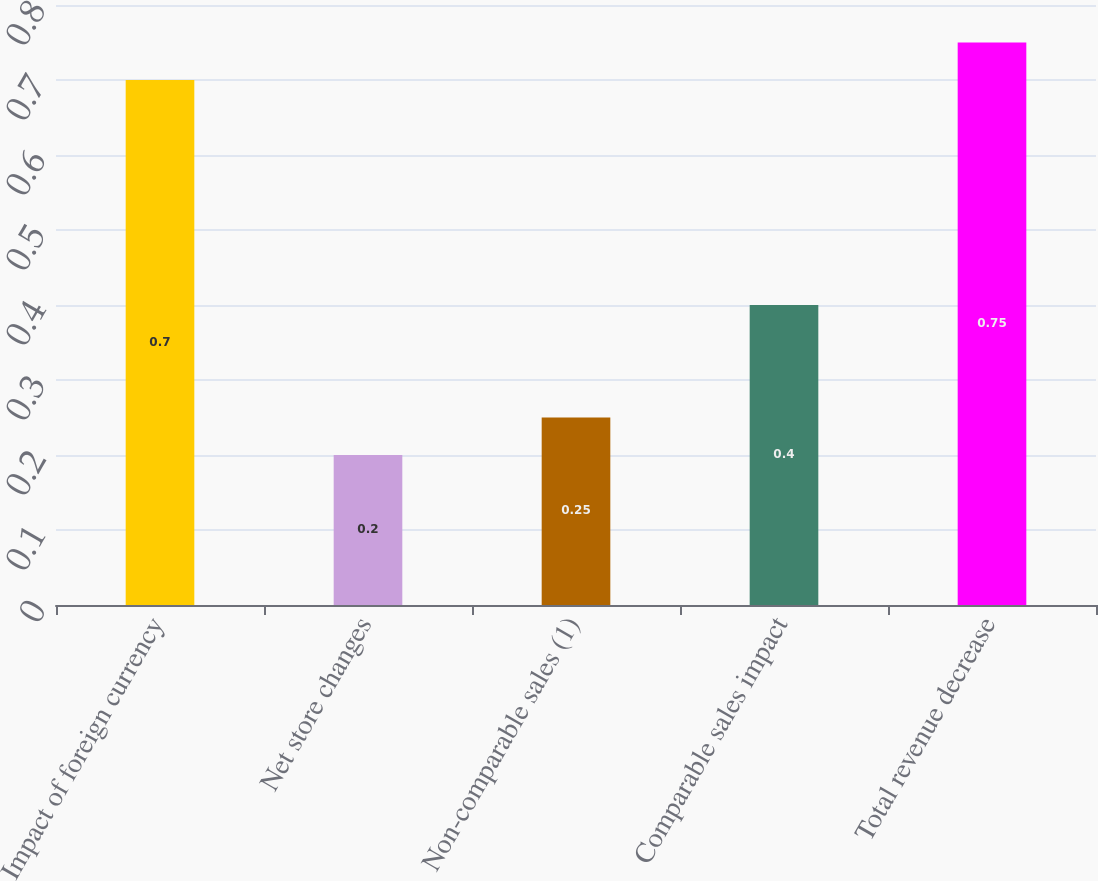<chart> <loc_0><loc_0><loc_500><loc_500><bar_chart><fcel>Impact of foreign currency<fcel>Net store changes<fcel>Non-comparable sales (1)<fcel>Comparable sales impact<fcel>Total revenue decrease<nl><fcel>0.7<fcel>0.2<fcel>0.25<fcel>0.4<fcel>0.75<nl></chart> 